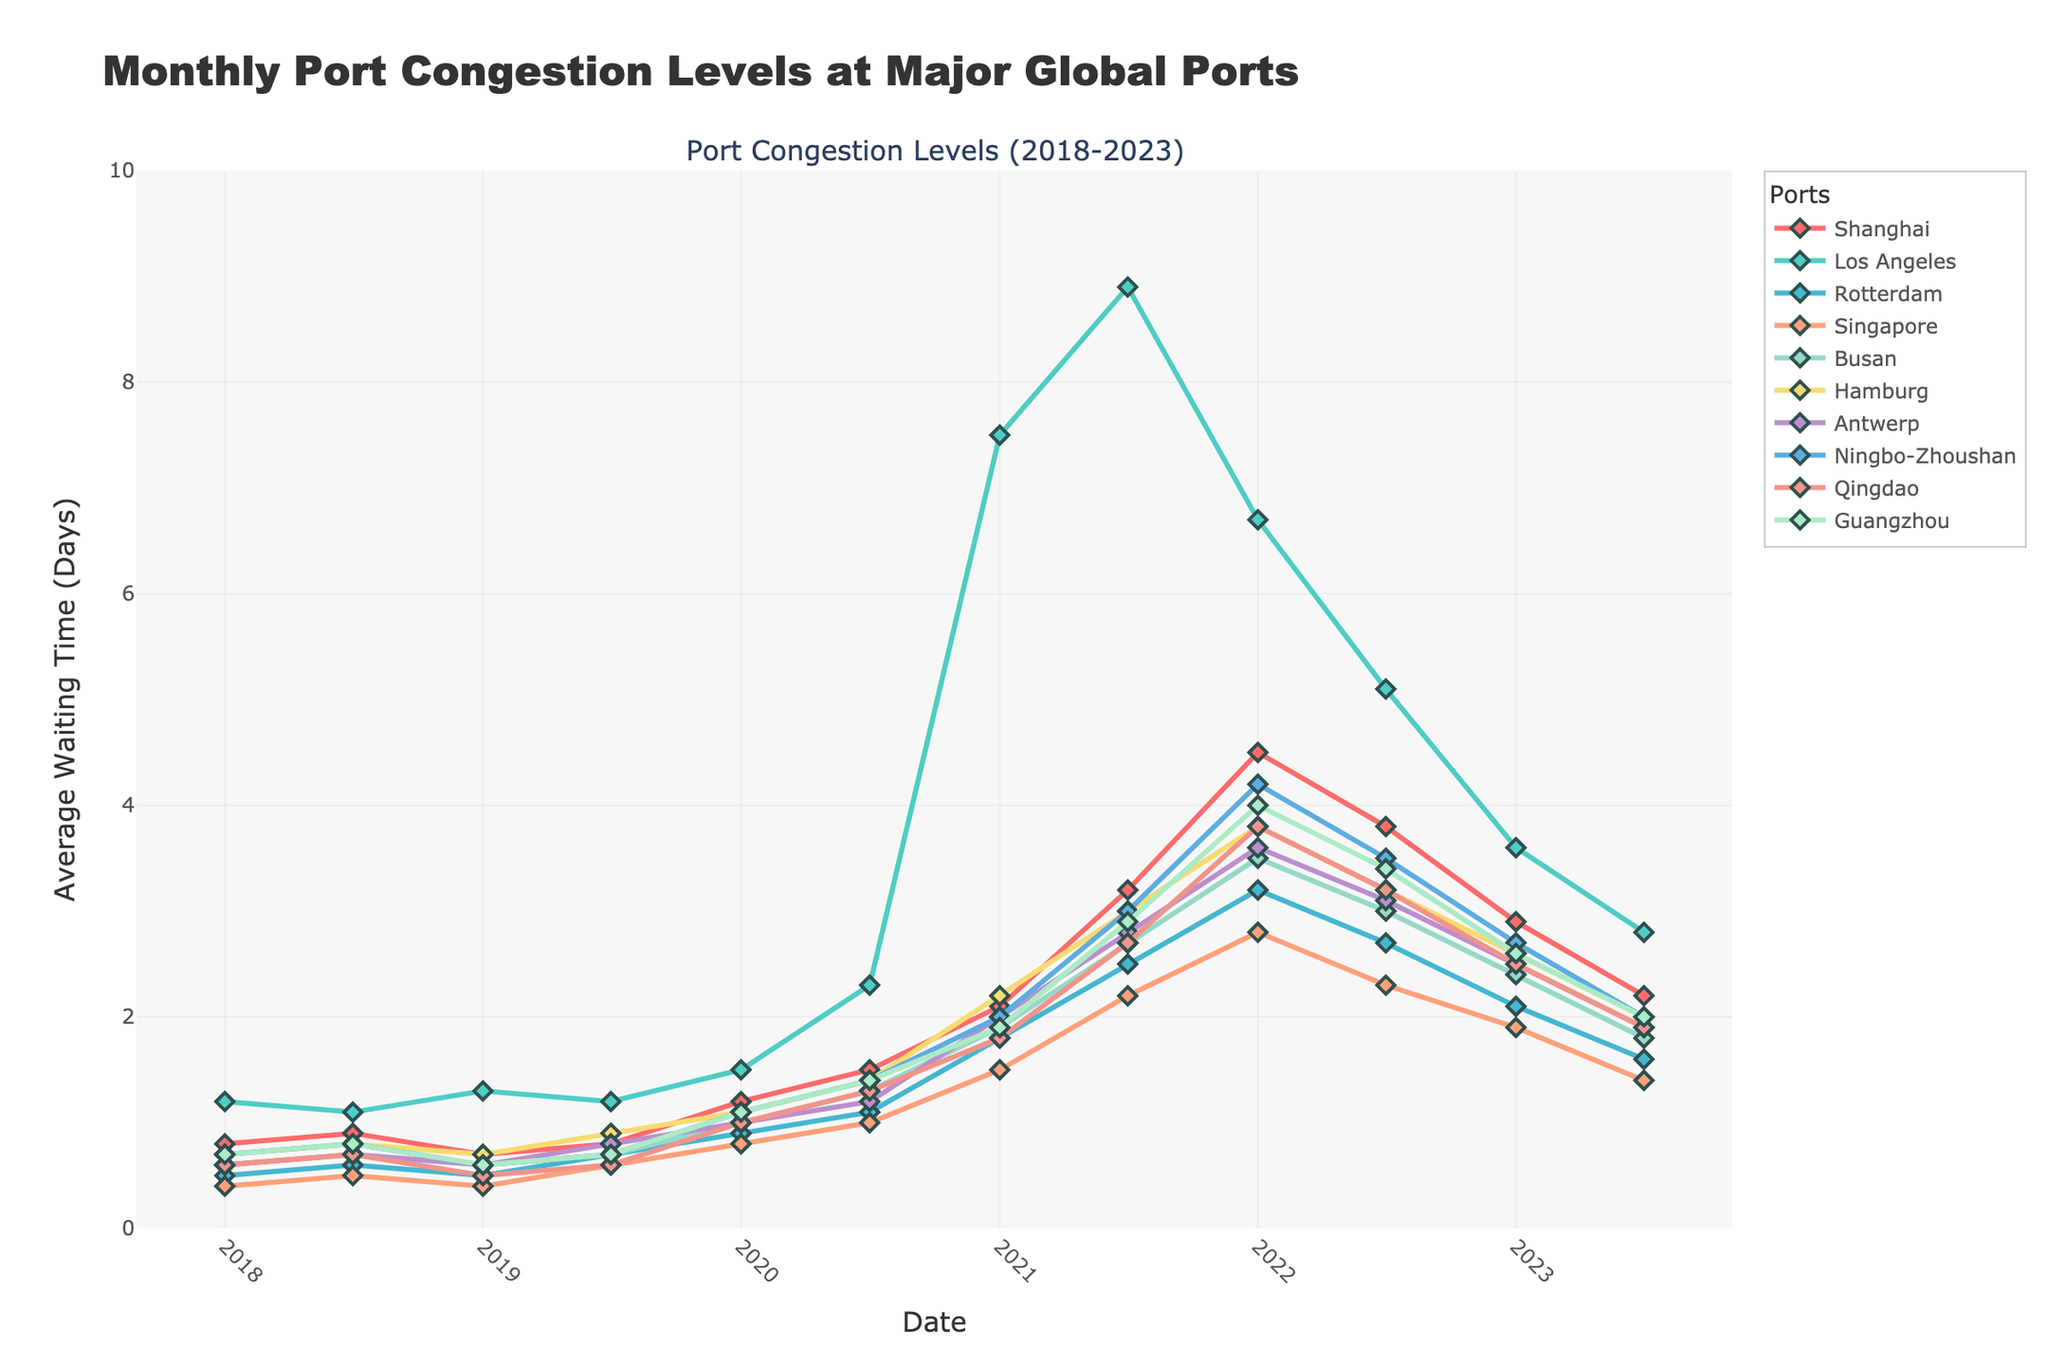which port had the highest congestion level in July 2021? Look at the values for each port in July 2021. The highest value is 8.9, which corresponds to Los Angeles.
Answer: Los Angeles between January 2020 and July 2023, how much did the average waiting time increase in Shanghai? The value in January 2020 for Shanghai is 1.2, and in July 2023 it is 2.2. The increase is 2.2 - 1.2 = 1.0 days.
Answer: 1.0 which ports experienced a peak in congestion in January 2022? Review the data for January 2022 across all ports. The peaks are seen where values are highest compared to other months. Los Angeles, Shanghai, Ningbo-Zhoushan, and Guangzhou stand out with 6.7, 4.5, 4.2, and 4.0 respectively.
Answer: Los Angeles, Shanghai, Ningbo-Zhoushan, Guangzhou what is the average congestion level in Los Angeles in 2021? The values for Los Angeles in 2021 are 7.5 (January) and 8.9 (July). The average is (7.5 + 8.9)/2 = 8.2 days.
Answer: 8.2 which port had the sharpest decline in congestion from January 2022 to July 2022? Calculate the difference between January 2022 and July 2022 values for each port. Los Angeles shows the sharpest decline from 6.7 to 5.1, a drop of 1.6 days.
Answer: Los Angeles did any port have a constant congestion level between any two consecutive points? Examine the data for each port. Qingdao maintained a constant level between January 2018 and July 2018 (both 0.6).
Answer: Qingdao which port had the most significant congestion increase from July 2019 to January 2021? Calculate the difference in values from July 2019 to January 2021 for each port. Los Angeles had an increase from 1.2 to 7.5, the largest in the dataset.
Answer: Los Angeles what was the overall trend in congestion levels for Rotterdam from 2018 to 2023? Observe Rotterdam's values from 2018 to 2023. There is an overall increasing trend that peaks in January 2022 at 3.2 before decreasing again.
Answer: Increasing then decreasing among the ports, which one showed the least variability in congestion levels across the entire period? Determine the range (max - min) for each port. Rotterdam has the smallest range (3.2 - 0.5 = 2.7), showing the least variability.
Answer: Rotterdam what is the combined average waiting time for all ports in January 2023? Sum up all the values for January 2023 and divide by the number of ports. The sum is 2.9+3.6+2.1+1.9+2.4+2.6+2.5+2.7+2.5+2.6 = 26.8; the average is 26.8/10 = 2.68 days.
Answer: 2.68 